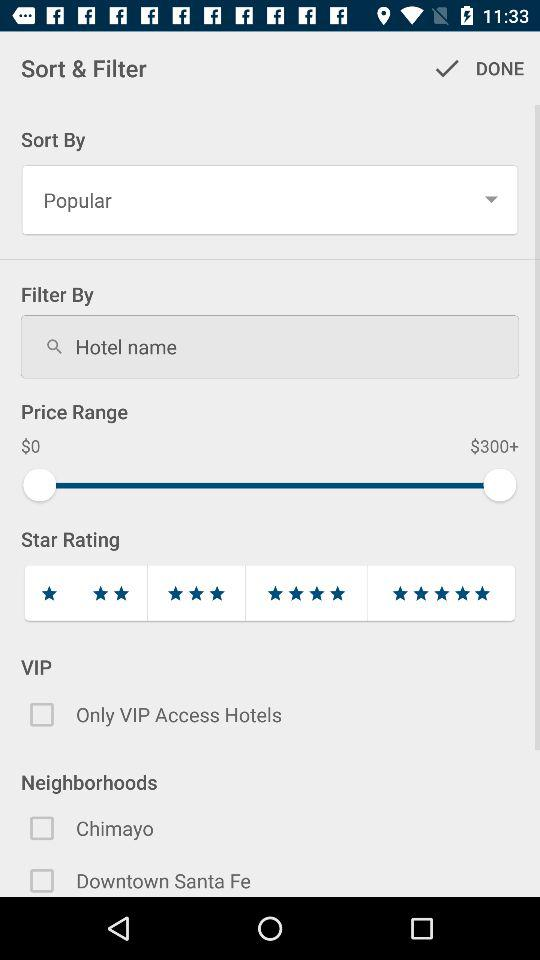How many neighborhoods are there?
Answer the question using a single word or phrase. 2 